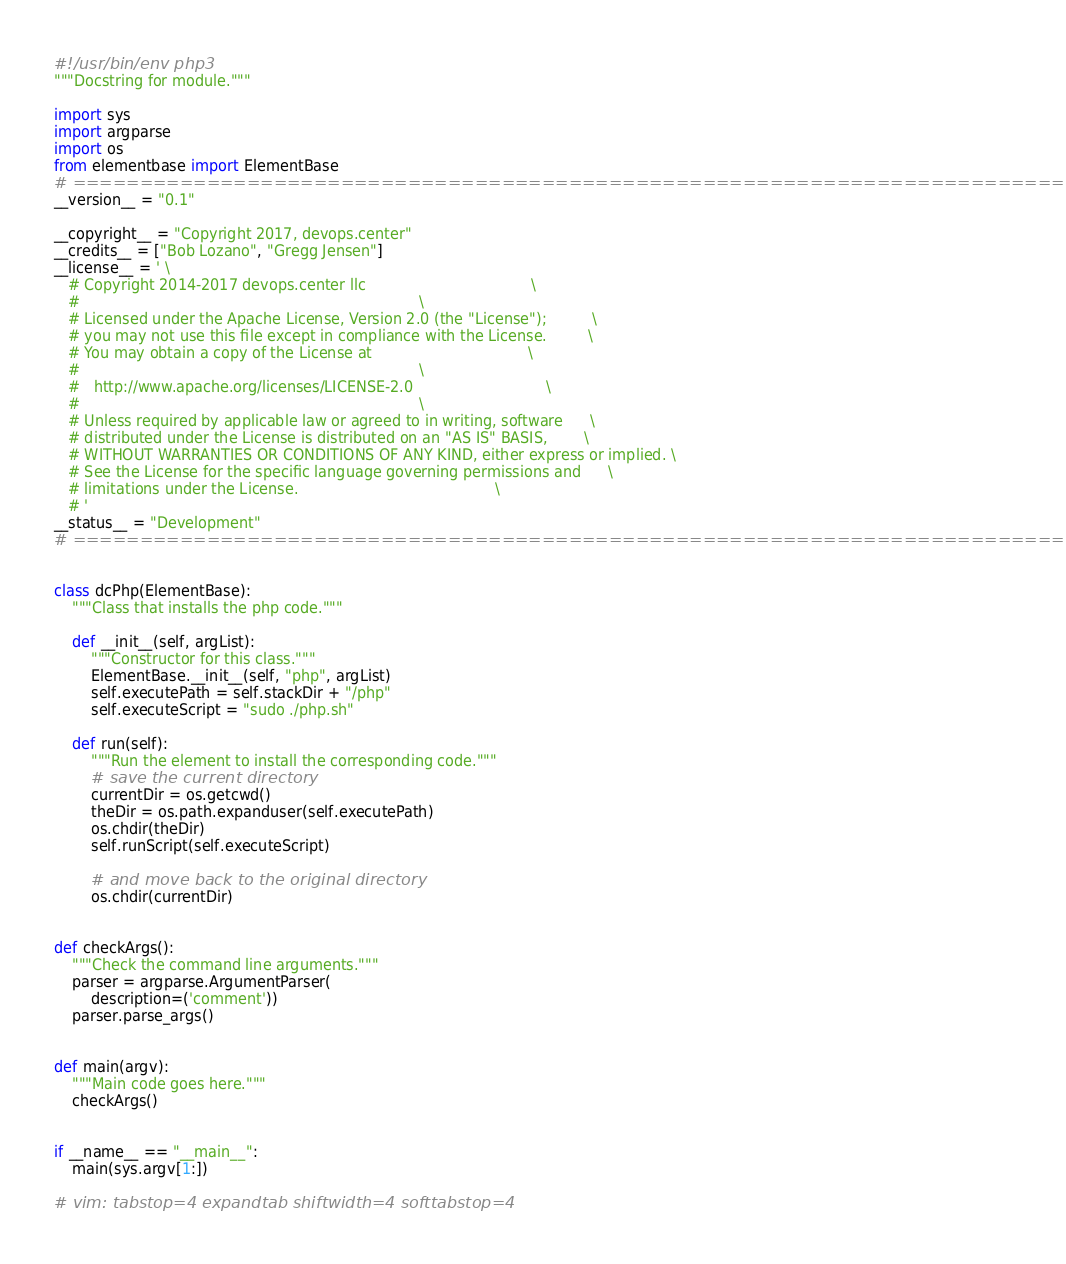<code> <loc_0><loc_0><loc_500><loc_500><_Python_>#!/usr/bin/env php3
"""Docstring for module."""

import sys
import argparse
import os
from elementbase import ElementBase
# ==============================================================================
__version__ = "0.1"

__copyright__ = "Copyright 2017, devops.center"
__credits__ = ["Bob Lozano", "Gregg Jensen"]
__license__ = ' \
   # Copyright 2014-2017 devops.center llc                                    \
   #                                                                          \
   # Licensed under the Apache License, Version 2.0 (the "License");          \
   # you may not use this file except in compliance with the License.         \
   # You may obtain a copy of the License at                                  \
   #                                                                          \
   #   http://www.apache.org/licenses/LICENSE-2.0                             \
   #                                                                          \
   # Unless required by applicable law or agreed to in writing, software      \
   # distributed under the License is distributed on an "AS IS" BASIS,        \
   # WITHOUT WARRANTIES OR CONDITIONS OF ANY KIND, either express or implied. \
   # See the License for the specific language governing permissions and      \
   # limitations under the License.                                           \
   # '
__status__ = "Development"
# ==============================================================================


class dcPhp(ElementBase):
    """Class that installs the php code."""

    def __init__(self, argList):
        """Constructor for this class."""
        ElementBase.__init__(self, "php", argList)
        self.executePath = self.stackDir + "/php"
        self.executeScript = "sudo ./php.sh"

    def run(self):
        """Run the element to install the corresponding code."""
        # save the current directory
        currentDir = os.getcwd()
        theDir = os.path.expanduser(self.executePath)
        os.chdir(theDir)
        self.runScript(self.executeScript)

        # and move back to the original directory
        os.chdir(currentDir)


def checkArgs():
    """Check the command line arguments."""
    parser = argparse.ArgumentParser(
        description=('comment'))
    parser.parse_args()


def main(argv):
    """Main code goes here."""
    checkArgs()


if __name__ == "__main__":
    main(sys.argv[1:])

# vim: tabstop=4 expandtab shiftwidth=4 softtabstop=4
</code> 